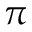<formula> <loc_0><loc_0><loc_500><loc_500>\pi</formula> 